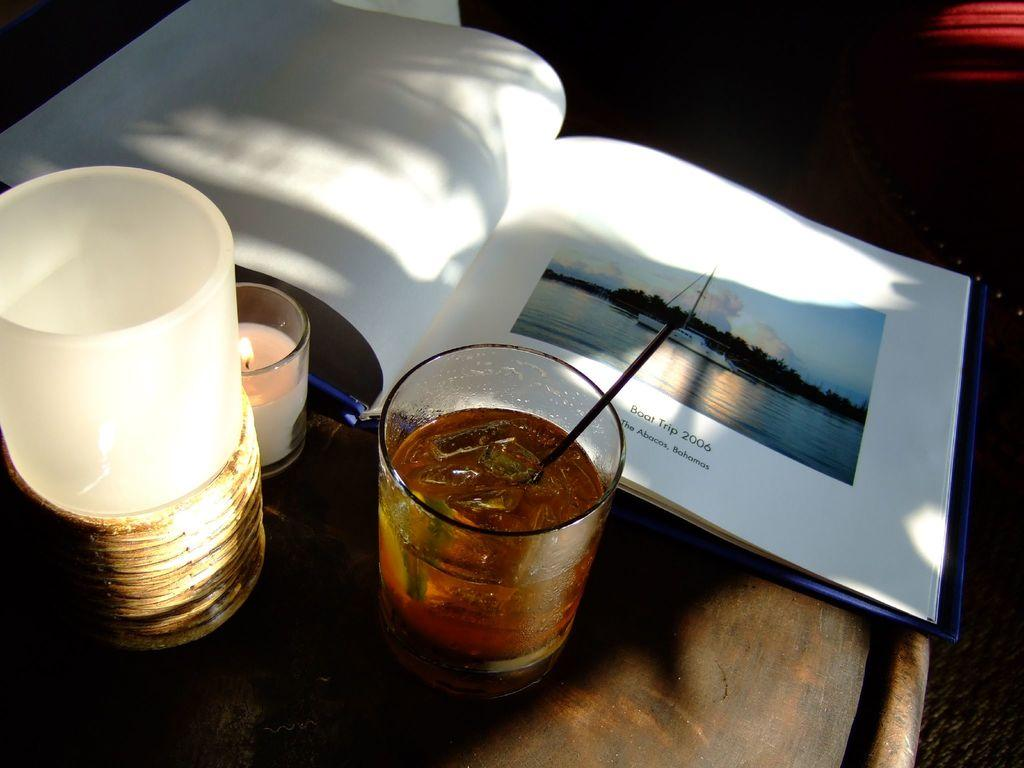<image>
Give a short and clear explanation of the subsequent image. Someone is drinking and looking at photos of their boat trip to the Bahamas in 2006. 